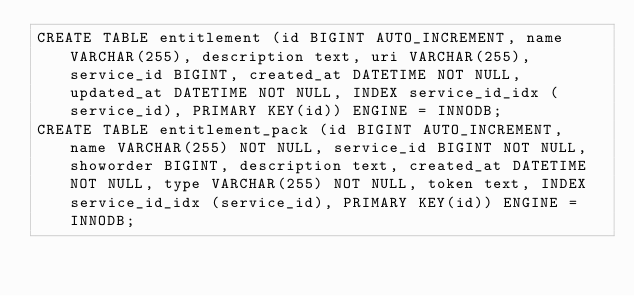Convert code to text. <code><loc_0><loc_0><loc_500><loc_500><_SQL_>CREATE TABLE entitlement (id BIGINT AUTO_INCREMENT, name VARCHAR(255), description text, uri VARCHAR(255), service_id BIGINT, created_at DATETIME NOT NULL, updated_at DATETIME NOT NULL, INDEX service_id_idx (service_id), PRIMARY KEY(id)) ENGINE = INNODB;
CREATE TABLE entitlement_pack (id BIGINT AUTO_INCREMENT, name VARCHAR(255) NOT NULL, service_id BIGINT NOT NULL, showorder BIGINT, description text, created_at DATETIME NOT NULL, type VARCHAR(255) NOT NULL, token text, INDEX service_id_idx (service_id), PRIMARY KEY(id)) ENGINE = INNODB;</code> 